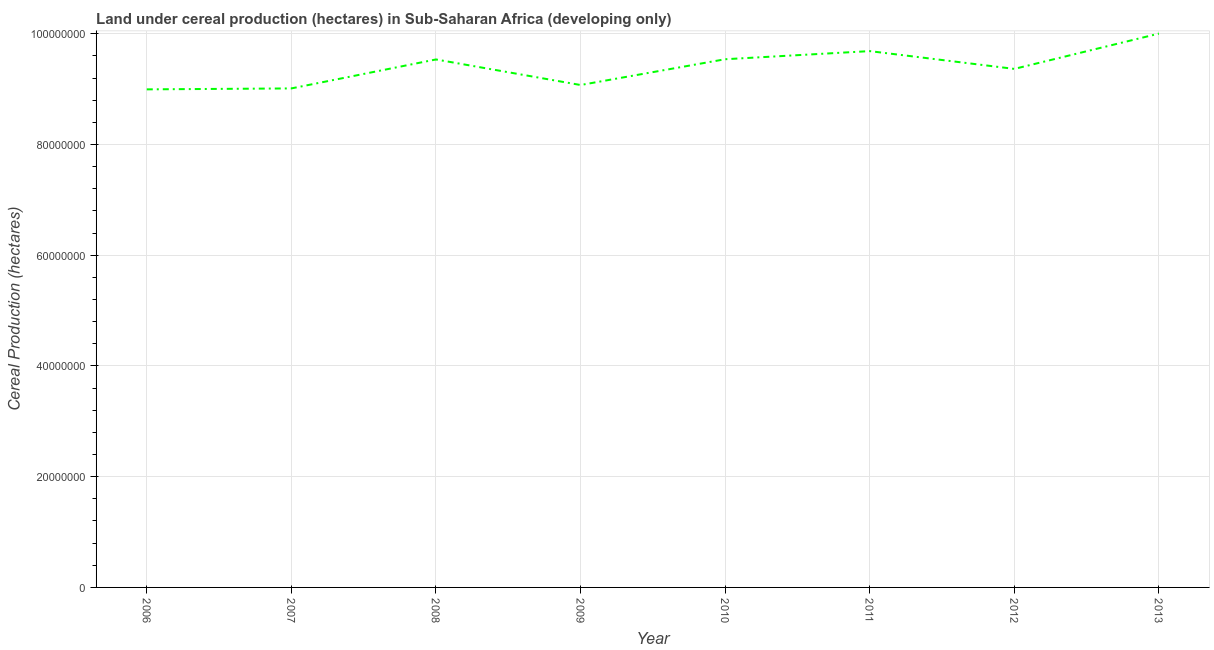What is the land under cereal production in 2011?
Your response must be concise. 9.69e+07. Across all years, what is the maximum land under cereal production?
Your answer should be compact. 1.00e+08. Across all years, what is the minimum land under cereal production?
Your answer should be compact. 9.00e+07. In which year was the land under cereal production minimum?
Make the answer very short. 2006. What is the sum of the land under cereal production?
Your response must be concise. 7.52e+08. What is the difference between the land under cereal production in 2007 and 2010?
Offer a terse response. -5.27e+06. What is the average land under cereal production per year?
Offer a very short reply. 9.40e+07. What is the median land under cereal production?
Make the answer very short. 9.45e+07. In how many years, is the land under cereal production greater than 60000000 hectares?
Offer a very short reply. 8. What is the ratio of the land under cereal production in 2009 to that in 2013?
Make the answer very short. 0.91. Is the land under cereal production in 2008 less than that in 2009?
Your answer should be compact. No. Is the difference between the land under cereal production in 2009 and 2013 greater than the difference between any two years?
Ensure brevity in your answer.  No. What is the difference between the highest and the second highest land under cereal production?
Offer a terse response. 3.16e+06. Is the sum of the land under cereal production in 2010 and 2011 greater than the maximum land under cereal production across all years?
Give a very brief answer. Yes. What is the difference between the highest and the lowest land under cereal production?
Ensure brevity in your answer.  1.01e+07. In how many years, is the land under cereal production greater than the average land under cereal production taken over all years?
Your answer should be compact. 4. Does the land under cereal production monotonically increase over the years?
Provide a short and direct response. No. How many years are there in the graph?
Provide a succinct answer. 8. What is the difference between two consecutive major ticks on the Y-axis?
Provide a short and direct response. 2.00e+07. Are the values on the major ticks of Y-axis written in scientific E-notation?
Your answer should be very brief. No. What is the title of the graph?
Offer a terse response. Land under cereal production (hectares) in Sub-Saharan Africa (developing only). What is the label or title of the Y-axis?
Your answer should be very brief. Cereal Production (hectares). What is the Cereal Production (hectares) in 2006?
Provide a succinct answer. 9.00e+07. What is the Cereal Production (hectares) of 2007?
Offer a terse response. 9.01e+07. What is the Cereal Production (hectares) of 2008?
Provide a succinct answer. 9.54e+07. What is the Cereal Production (hectares) in 2009?
Offer a terse response. 9.07e+07. What is the Cereal Production (hectares) of 2010?
Provide a short and direct response. 9.54e+07. What is the Cereal Production (hectares) of 2011?
Keep it short and to the point. 9.69e+07. What is the Cereal Production (hectares) in 2012?
Provide a short and direct response. 9.37e+07. What is the Cereal Production (hectares) of 2013?
Your response must be concise. 1.00e+08. What is the difference between the Cereal Production (hectares) in 2006 and 2007?
Make the answer very short. -1.70e+05. What is the difference between the Cereal Production (hectares) in 2006 and 2008?
Make the answer very short. -5.40e+06. What is the difference between the Cereal Production (hectares) in 2006 and 2009?
Give a very brief answer. -7.85e+05. What is the difference between the Cereal Production (hectares) in 2006 and 2010?
Provide a succinct answer. -5.44e+06. What is the difference between the Cereal Production (hectares) in 2006 and 2011?
Ensure brevity in your answer.  -6.91e+06. What is the difference between the Cereal Production (hectares) in 2006 and 2012?
Keep it short and to the point. -3.70e+06. What is the difference between the Cereal Production (hectares) in 2006 and 2013?
Give a very brief answer. -1.01e+07. What is the difference between the Cereal Production (hectares) in 2007 and 2008?
Make the answer very short. -5.23e+06. What is the difference between the Cereal Production (hectares) in 2007 and 2009?
Offer a very short reply. -6.15e+05. What is the difference between the Cereal Production (hectares) in 2007 and 2010?
Keep it short and to the point. -5.27e+06. What is the difference between the Cereal Production (hectares) in 2007 and 2011?
Provide a short and direct response. -6.74e+06. What is the difference between the Cereal Production (hectares) in 2007 and 2012?
Your answer should be compact. -3.53e+06. What is the difference between the Cereal Production (hectares) in 2007 and 2013?
Make the answer very short. -9.90e+06. What is the difference between the Cereal Production (hectares) in 2008 and 2009?
Your answer should be compact. 4.62e+06. What is the difference between the Cereal Production (hectares) in 2008 and 2010?
Provide a succinct answer. -4.02e+04. What is the difference between the Cereal Production (hectares) in 2008 and 2011?
Keep it short and to the point. -1.51e+06. What is the difference between the Cereal Production (hectares) in 2008 and 2012?
Offer a terse response. 1.70e+06. What is the difference between the Cereal Production (hectares) in 2008 and 2013?
Give a very brief answer. -4.67e+06. What is the difference between the Cereal Production (hectares) in 2009 and 2010?
Give a very brief answer. -4.66e+06. What is the difference between the Cereal Production (hectares) in 2009 and 2011?
Your answer should be very brief. -6.12e+06. What is the difference between the Cereal Production (hectares) in 2009 and 2012?
Make the answer very short. -2.91e+06. What is the difference between the Cereal Production (hectares) in 2009 and 2013?
Offer a very short reply. -9.28e+06. What is the difference between the Cereal Production (hectares) in 2010 and 2011?
Make the answer very short. -1.47e+06. What is the difference between the Cereal Production (hectares) in 2010 and 2012?
Keep it short and to the point. 1.74e+06. What is the difference between the Cereal Production (hectares) in 2010 and 2013?
Give a very brief answer. -4.63e+06. What is the difference between the Cereal Production (hectares) in 2011 and 2012?
Keep it short and to the point. 3.21e+06. What is the difference between the Cereal Production (hectares) in 2011 and 2013?
Provide a succinct answer. -3.16e+06. What is the difference between the Cereal Production (hectares) in 2012 and 2013?
Offer a very short reply. -6.37e+06. What is the ratio of the Cereal Production (hectares) in 2006 to that in 2007?
Provide a short and direct response. 1. What is the ratio of the Cereal Production (hectares) in 2006 to that in 2008?
Provide a short and direct response. 0.94. What is the ratio of the Cereal Production (hectares) in 2006 to that in 2009?
Ensure brevity in your answer.  0.99. What is the ratio of the Cereal Production (hectares) in 2006 to that in 2010?
Make the answer very short. 0.94. What is the ratio of the Cereal Production (hectares) in 2006 to that in 2011?
Offer a terse response. 0.93. What is the ratio of the Cereal Production (hectares) in 2006 to that in 2013?
Your response must be concise. 0.9. What is the ratio of the Cereal Production (hectares) in 2007 to that in 2008?
Give a very brief answer. 0.94. What is the ratio of the Cereal Production (hectares) in 2007 to that in 2010?
Provide a short and direct response. 0.94. What is the ratio of the Cereal Production (hectares) in 2007 to that in 2011?
Keep it short and to the point. 0.93. What is the ratio of the Cereal Production (hectares) in 2007 to that in 2013?
Provide a succinct answer. 0.9. What is the ratio of the Cereal Production (hectares) in 2008 to that in 2009?
Offer a very short reply. 1.05. What is the ratio of the Cereal Production (hectares) in 2008 to that in 2010?
Ensure brevity in your answer.  1. What is the ratio of the Cereal Production (hectares) in 2008 to that in 2011?
Offer a terse response. 0.98. What is the ratio of the Cereal Production (hectares) in 2008 to that in 2012?
Your answer should be compact. 1.02. What is the ratio of the Cereal Production (hectares) in 2008 to that in 2013?
Keep it short and to the point. 0.95. What is the ratio of the Cereal Production (hectares) in 2009 to that in 2010?
Offer a very short reply. 0.95. What is the ratio of the Cereal Production (hectares) in 2009 to that in 2011?
Provide a short and direct response. 0.94. What is the ratio of the Cereal Production (hectares) in 2009 to that in 2012?
Give a very brief answer. 0.97. What is the ratio of the Cereal Production (hectares) in 2009 to that in 2013?
Offer a terse response. 0.91. What is the ratio of the Cereal Production (hectares) in 2010 to that in 2011?
Your answer should be very brief. 0.98. What is the ratio of the Cereal Production (hectares) in 2010 to that in 2013?
Ensure brevity in your answer.  0.95. What is the ratio of the Cereal Production (hectares) in 2011 to that in 2012?
Offer a terse response. 1.03. What is the ratio of the Cereal Production (hectares) in 2012 to that in 2013?
Provide a short and direct response. 0.94. 